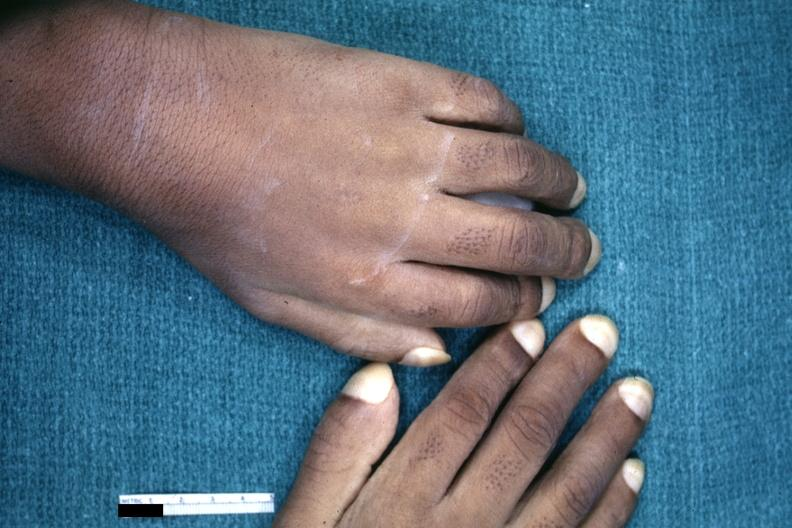how does this image show childs hands?
Answer the question using a single word or phrase. With obvious clubbing 